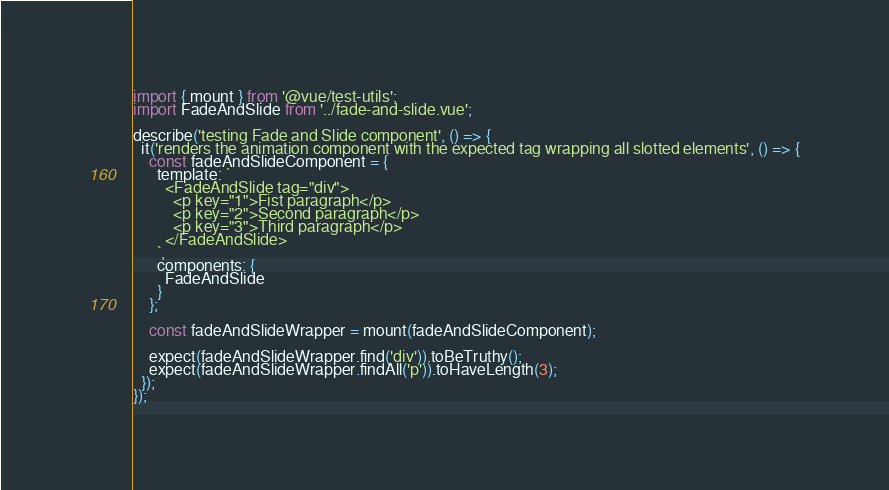<code> <loc_0><loc_0><loc_500><loc_500><_TypeScript_>import { mount } from '@vue/test-utils';
import FadeAndSlide from '../fade-and-slide.vue';

describe('testing Fade and Slide component', () => {
  it('renders the animation component with the expected tag wrapping all slotted elements', () => {
    const fadeAndSlideComponent = {
      template: `
        <FadeAndSlide tag="div">
          <p key="1">Fist paragraph</p>
          <p key="2">Second paragraph</p>
          <p key="3">Third paragraph</p>
        </FadeAndSlide>
      `,
      components: {
        FadeAndSlide
      }
    };

    const fadeAndSlideWrapper = mount(fadeAndSlideComponent);

    expect(fadeAndSlideWrapper.find('div')).toBeTruthy();
    expect(fadeAndSlideWrapper.findAll('p')).toHaveLength(3);
  });
});
</code> 